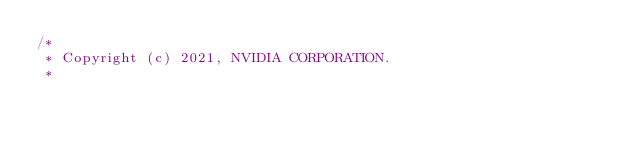<code> <loc_0><loc_0><loc_500><loc_500><_Cuda_>/*
 * Copyright (c) 2021, NVIDIA CORPORATION.
 *</code> 